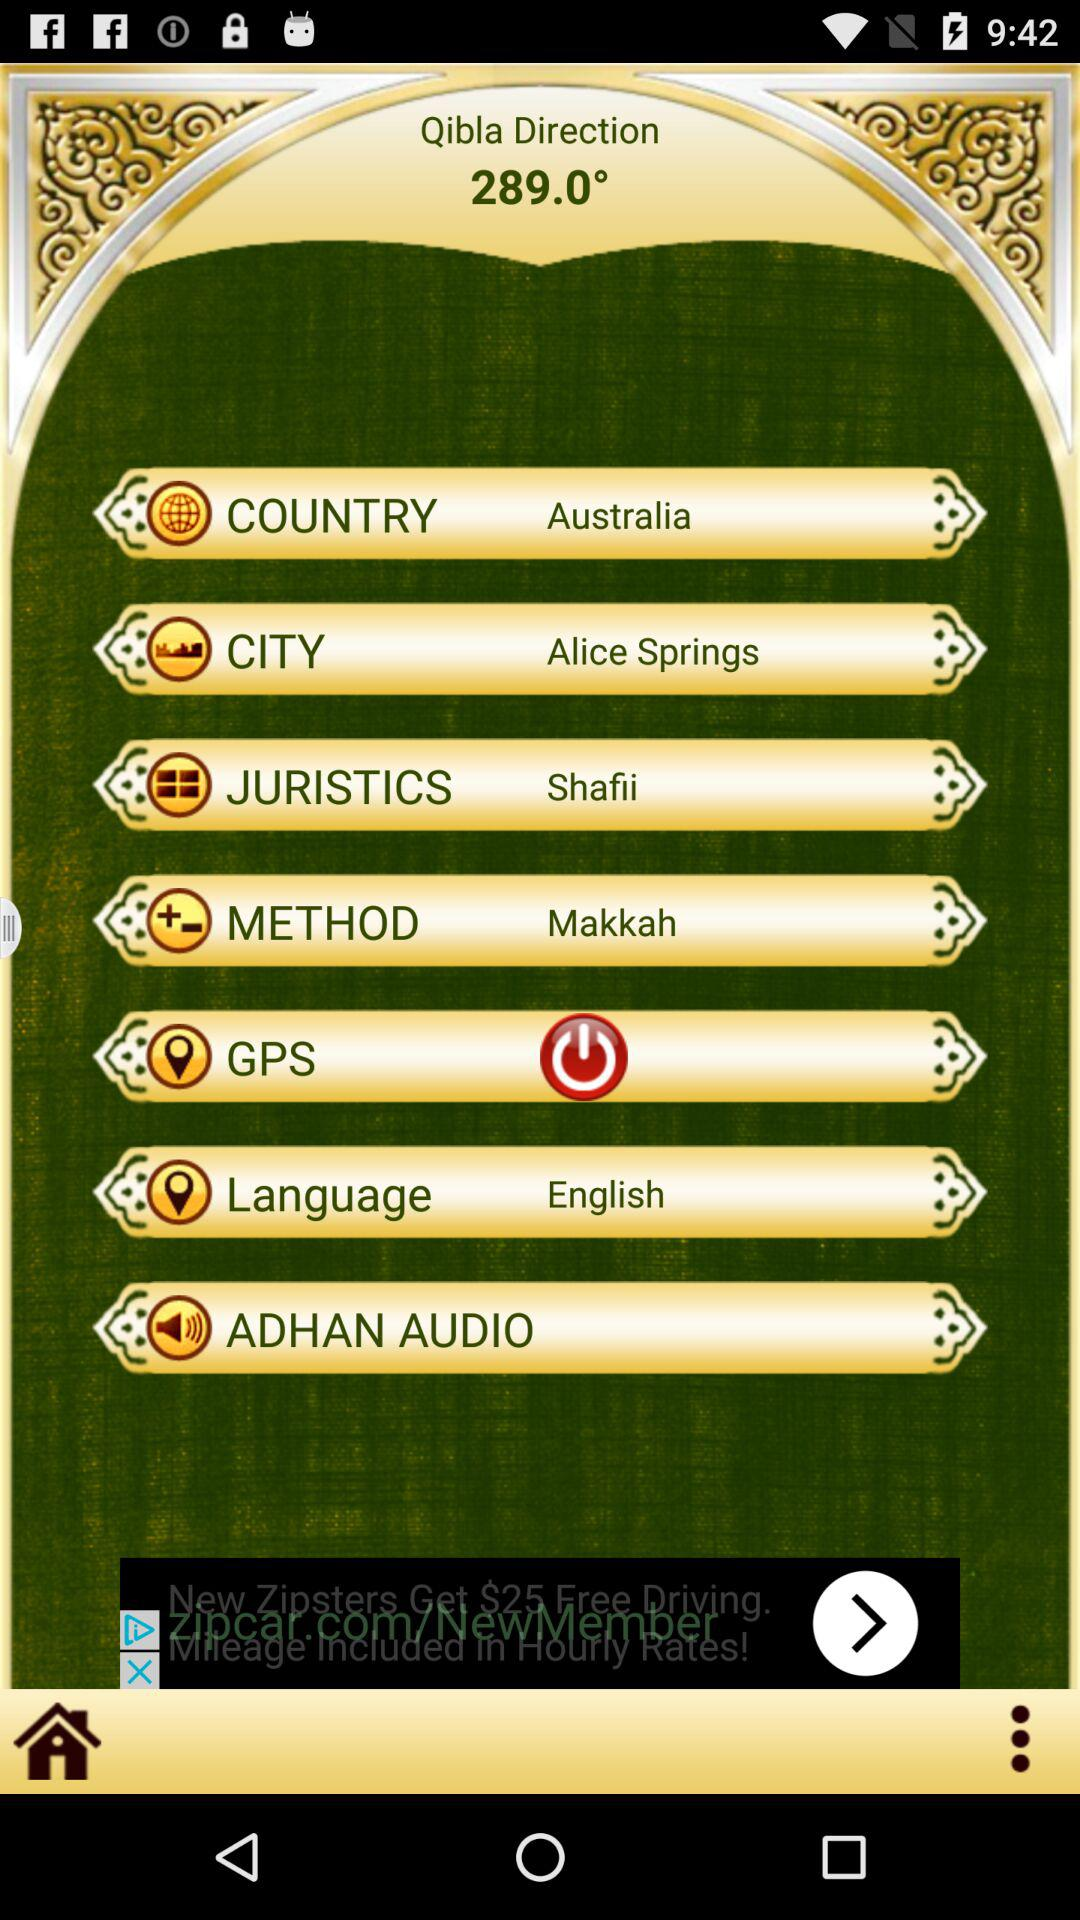What is the selected country? The selected country is Australia. 